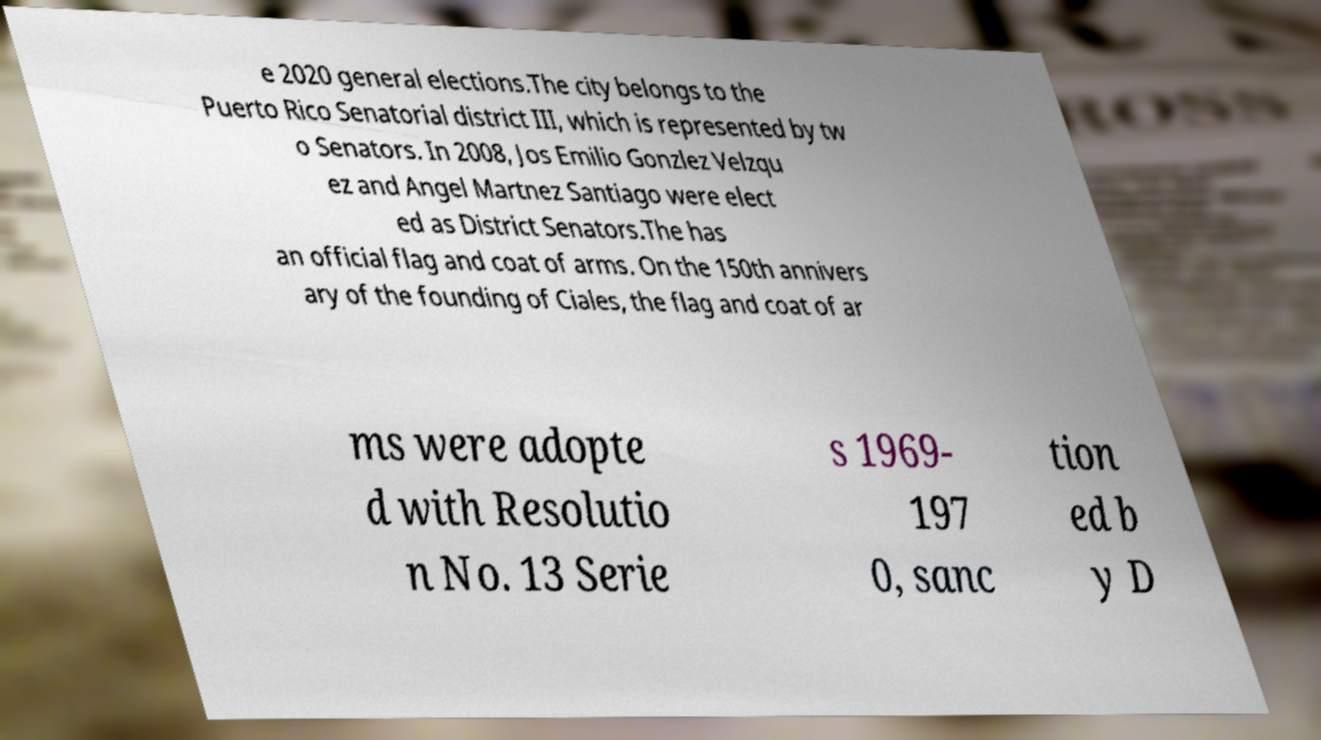I need the written content from this picture converted into text. Can you do that? e 2020 general elections.The city belongs to the Puerto Rico Senatorial district III, which is represented by tw o Senators. In 2008, Jos Emilio Gonzlez Velzqu ez and Angel Martnez Santiago were elect ed as District Senators.The has an official flag and coat of arms. On the 150th annivers ary of the founding of Ciales, the flag and coat of ar ms were adopte d with Resolutio n No. 13 Serie s 1969- 197 0, sanc tion ed b y D 